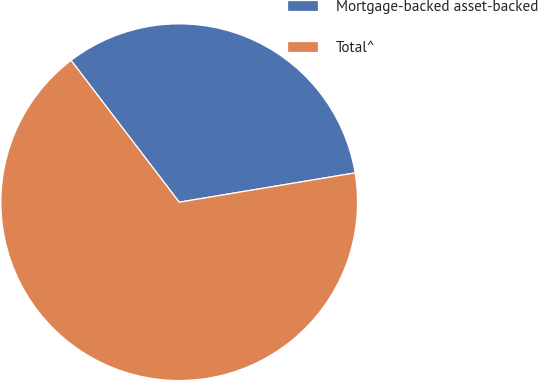Convert chart to OTSL. <chart><loc_0><loc_0><loc_500><loc_500><pie_chart><fcel>Mortgage-backed asset-backed<fcel>Total^<nl><fcel>32.74%<fcel>67.26%<nl></chart> 